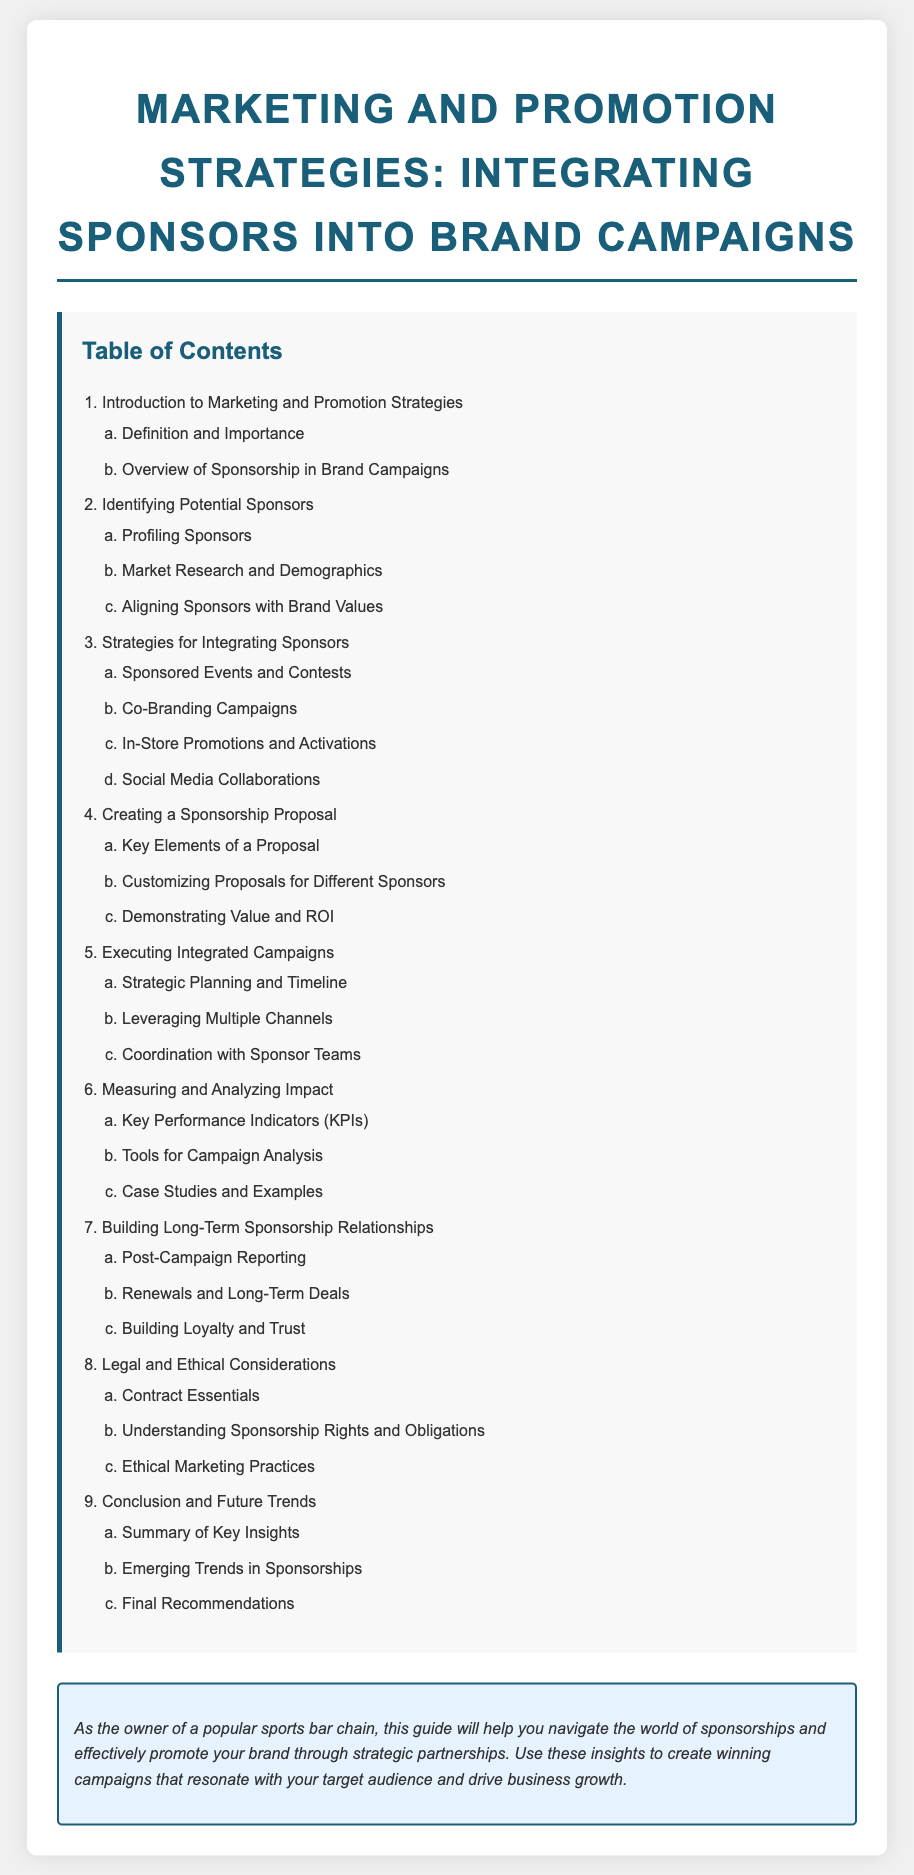what is the title of the document? The title is a key identifier of the document, which states the focus areas regarding marketing and sponsorships.
Answer: Marketing and Promotion Strategies: Integrating Sponsors into Brand Campaigns how many main sections are there in the table of contents? The number of main sections gives insight into the organization of the content and topics covered.
Answer: Nine what is the first sub-section under "Identifying Potential Sponsors"? The sub-section provides specific focus areas related to understanding potential sponsors.
Answer: Profiling Sponsors what strategy involves "Social Media Collaborations"? This strategy highlights modern approaches in integrating sponsors with brand campaigns via digital platforms.
Answer: Strategies for Integrating Sponsors what is the last sub-section under "Conclusion and Future Trends"? The last sub-section helps summarize future directions and recommendations in the context of sponsorships.
Answer: Final Recommendations what is emphasized in the "sponsor-note"? This provides insight into the overall purpose of the document and its relevance to the target audience.
Answer: Strategic partnerships how many elements are included in creating a sponsorship proposal? This gives a quick insight into the complexity and requirements for effective proposals in sponsorships.
Answer: Three 